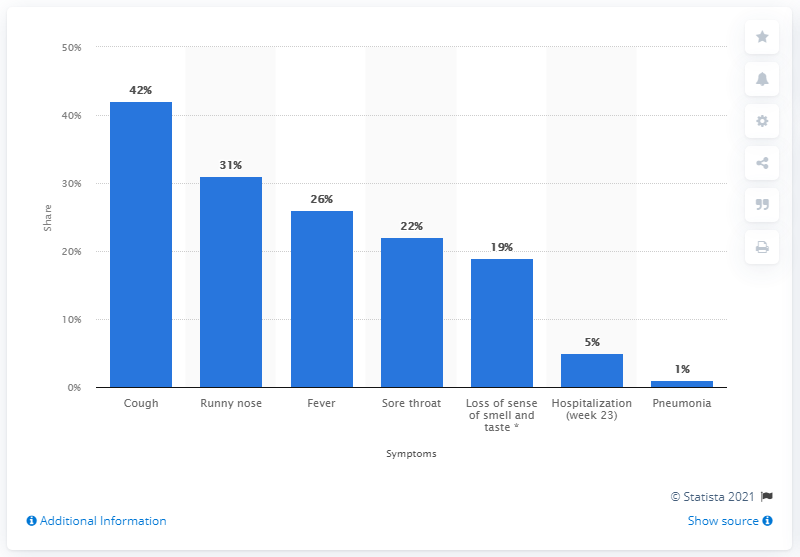Indicate a few pertinent items in this graphic. The combined percentage of the three least popular symptoms was 25%. The third most common symptom caused by the coronavirus is fever. 